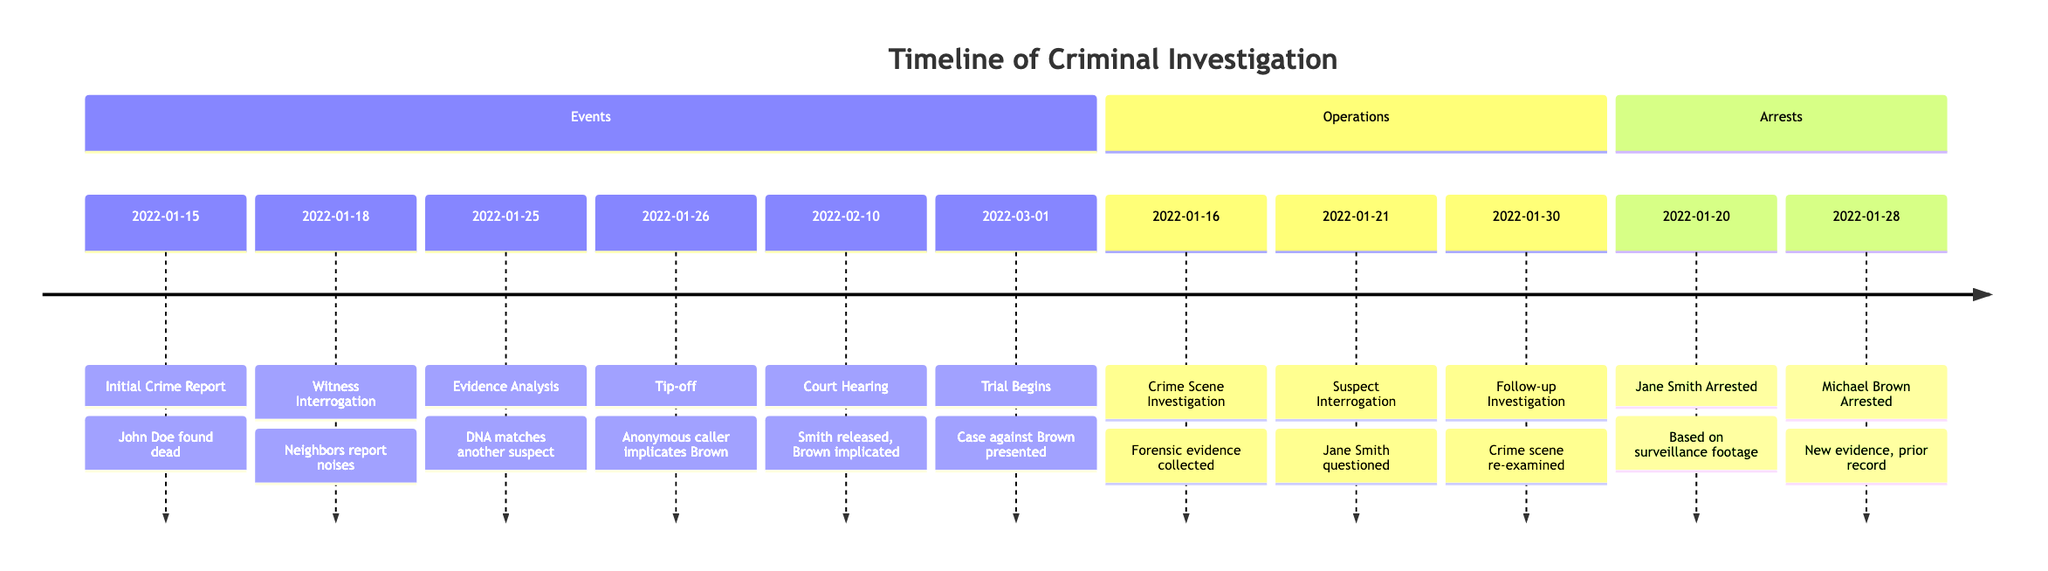What is the date of the initial crime report? The first event listed in the "Events" section is dated 2022-01-15, which indicates the date of the initial crime report regarding John Doe's death.
Answer: 2022-01-15 How many arrests are recorded in the timeline? In the "Arrests" section, there are two specific incidents listed: the arrest of Jane Smith and the arrest of Michael Brown, which totals to two arrests.
Answer: 2 What was the result of the court hearing on 2022-02-10? The annotation for the court hearing on this date states that Smith was released and Brown was implicated, showing the outcome regarding the implicated suspect at the hearing.
Answer: Smith released, Brown implicated What operation occurred immediately after the initial crime report? The timeline indicates that a Crime Scene Investigation took place on 2022-01-16, immediately following the initial crime report on 2022-01-15, making it the next operation chronologically.
Answer: Crime Scene Investigation Which suspect was arrested first? The "Arrests" section shows Jane Smith was arrested on 2022-01-20, while Michael Brown was arrested later on 2022-01-28, indicating that Jane Smith was the first suspect to be arrested.
Answer: Jane Smith What type of evidence matched a suspect on 2022-01-25? The summary for the event on this date mentions that DNA evidence matched another suspect, indicating the nature of the evidence that was relevant in the investigation.
Answer: DNA What significant event occurred on 2022-03-01? The timeline specifies that on this date the trial against Brown began, marking it as a significant milestone in the investigation timeline.
Answer: Trial Begins What was collected during the Crime Scene Investigation on 2022-01-16? The annotation for that operation states that forensic evidence was collected, indicating what was the focus of the investigation at that time.
Answer: Forensic evidence What triggered the tip-off on 2022-01-26? An anonymous caller implicated Brown, which is specifically noted in the timeline as a critical point of interest leading up to his arrest.
Answer: Anonymous caller implicates Brown 